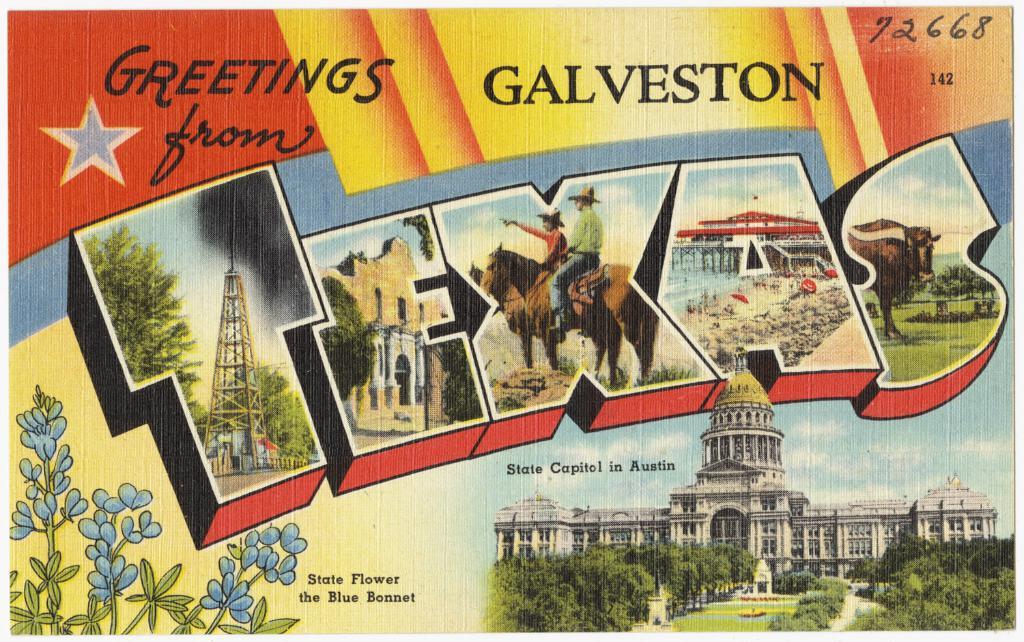What city in texas is this about?
Offer a terse response. Galveston. Is galveston, texas a beautiful place?
Your response must be concise. Answering does not require reading text in the image. 